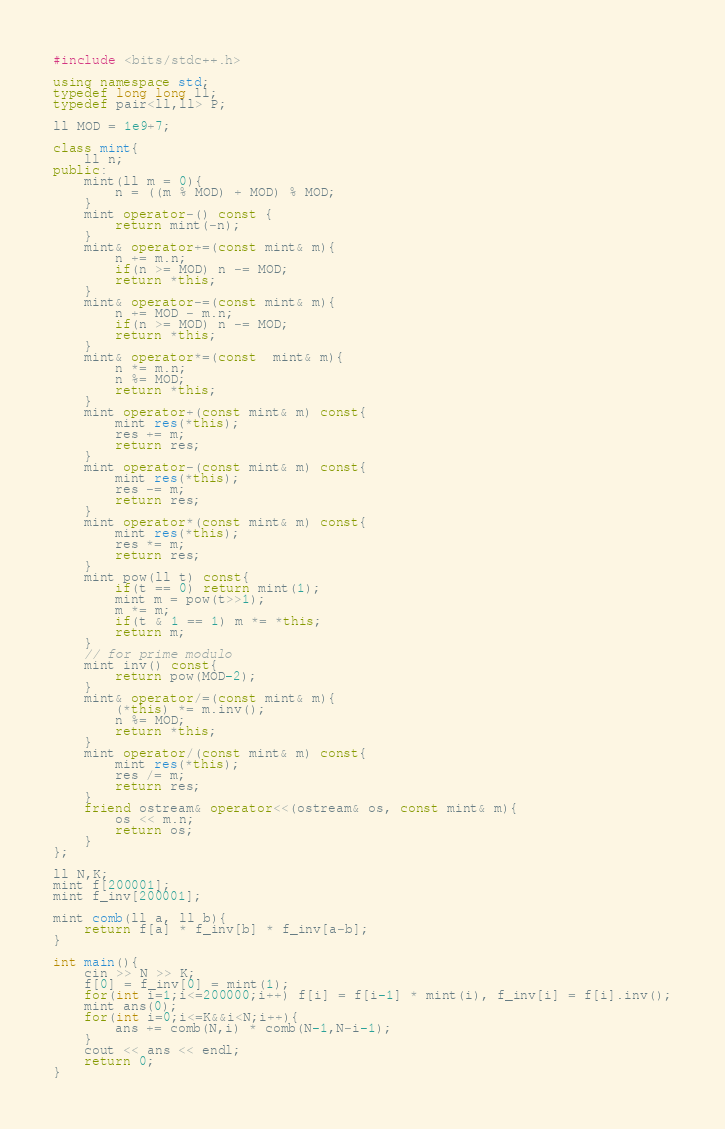Convert code to text. <code><loc_0><loc_0><loc_500><loc_500><_C++_>#include <bits/stdc++.h>

using namespace std;
typedef long long ll;
typedef pair<ll,ll> P;

ll MOD = 1e9+7;

class mint{
    ll n;
public:
    mint(ll m = 0){
        n = ((m % MOD) + MOD) % MOD;
    }
    mint operator-() const {
        return mint(-n);
    }
    mint& operator+=(const mint& m){
        n += m.n;
        if(n >= MOD) n -= MOD;
        return *this;
    }
    mint& operator-=(const mint& m){
        n += MOD - m.n;
        if(n >= MOD) n -= MOD;
        return *this;
    }
    mint& operator*=(const  mint& m){
        n *= m.n;
        n %= MOD;
        return *this;
    }
    mint operator+(const mint& m) const{
        mint res(*this);
        res += m;
        return res;
    }
    mint operator-(const mint& m) const{
        mint res(*this);
        res -= m;
        return res;
    }
    mint operator*(const mint& m) const{
        mint res(*this);
        res *= m;
        return res;
    }
    mint pow(ll t) const{
        if(t == 0) return mint(1);
        mint m = pow(t>>1);
        m *= m;
        if(t & 1 == 1) m *= *this;
        return m;
    }
    // for prime modulo
    mint inv() const{
        return pow(MOD-2);
    }
    mint& operator/=(const mint& m){
        (*this) *= m.inv();
        n %= MOD;
        return *this;
    }
    mint operator/(const mint& m) const{
        mint res(*this);
        res /= m;
        return res;
    }
    friend ostream& operator<<(ostream& os, const mint& m){
        os << m.n;
        return os;
    }
};

ll N,K;
mint f[200001];
mint f_inv[200001];

mint comb(ll a, ll b){
    return f[a] * f_inv[b] * f_inv[a-b];
}

int main(){
    cin >> N >> K;
    f[0] = f_inv[0] = mint(1);
    for(int i=1;i<=200000;i++) f[i] = f[i-1] * mint(i), f_inv[i] = f[i].inv();
    mint ans(0);
    for(int i=0;i<=K&&i<N;i++){
        ans += comb(N,i) * comb(N-1,N-i-1);
    }
    cout << ans << endl;
    return 0;
}</code> 